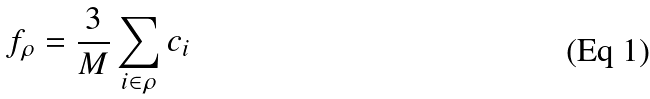<formula> <loc_0><loc_0><loc_500><loc_500>f _ { \rho } = \frac { 3 } { M } \sum _ { i \in \rho } c _ { i }</formula> 